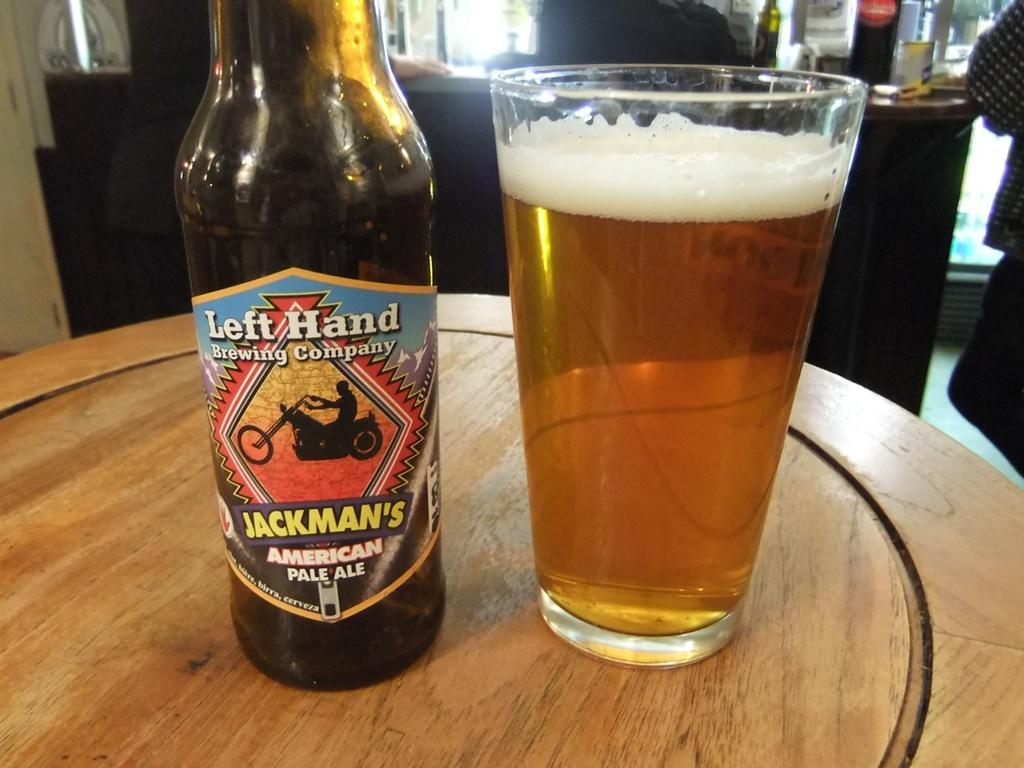<image>
Give a short and clear explanation of the subsequent image. A bottle of Jackman's American pale ale next to a glass 